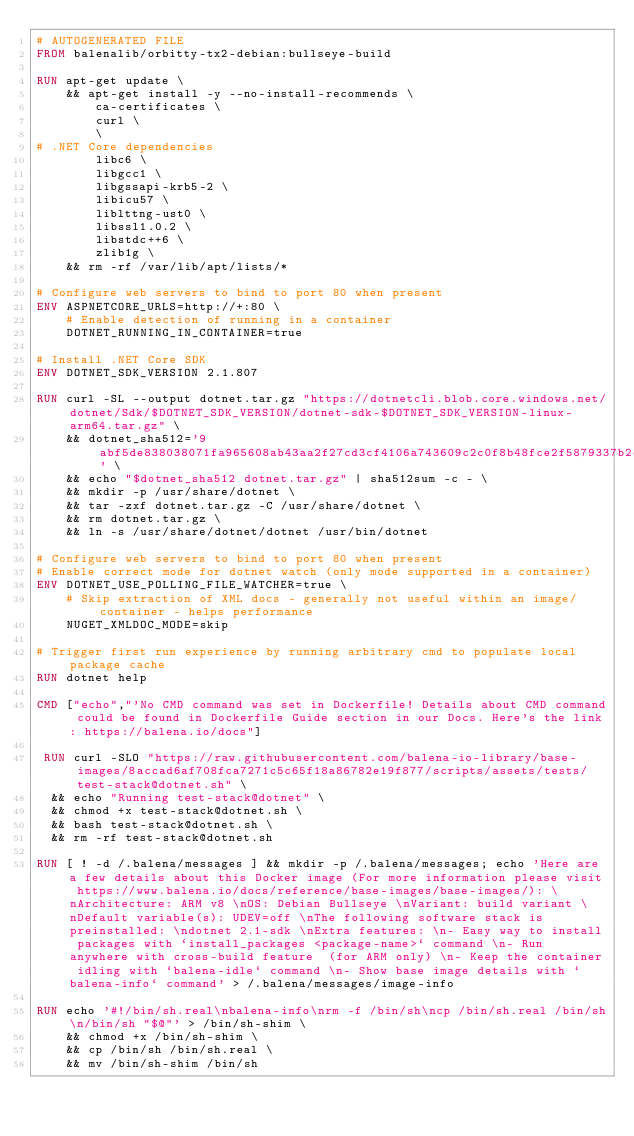<code> <loc_0><loc_0><loc_500><loc_500><_Dockerfile_># AUTOGENERATED FILE
FROM balenalib/orbitty-tx2-debian:bullseye-build

RUN apt-get update \
    && apt-get install -y --no-install-recommends \
        ca-certificates \
        curl \
        \
# .NET Core dependencies
        libc6 \
        libgcc1 \
        libgssapi-krb5-2 \
        libicu57 \
        liblttng-ust0 \
        libssl1.0.2 \
        libstdc++6 \
        zlib1g \
    && rm -rf /var/lib/apt/lists/*

# Configure web servers to bind to port 80 when present
ENV ASPNETCORE_URLS=http://+:80 \
    # Enable detection of running in a container
    DOTNET_RUNNING_IN_CONTAINER=true

# Install .NET Core SDK
ENV DOTNET_SDK_VERSION 2.1.807

RUN curl -SL --output dotnet.tar.gz "https://dotnetcli.blob.core.windows.net/dotnet/Sdk/$DOTNET_SDK_VERSION/dotnet-sdk-$DOTNET_SDK_VERSION-linux-arm64.tar.gz" \
    && dotnet_sha512='9abf5de838038071fa965608ab43aa2f27cd3cf4106a743609c2c0f8b48fce2f5879337b2cfa1861d16c2bf5bb570bc9f9985240ce94805b46e32bc619476c83' \
    && echo "$dotnet_sha512 dotnet.tar.gz" | sha512sum -c - \
    && mkdir -p /usr/share/dotnet \
    && tar -zxf dotnet.tar.gz -C /usr/share/dotnet \
    && rm dotnet.tar.gz \
    && ln -s /usr/share/dotnet/dotnet /usr/bin/dotnet

# Configure web servers to bind to port 80 when present
# Enable correct mode for dotnet watch (only mode supported in a container)
ENV DOTNET_USE_POLLING_FILE_WATCHER=true \
    # Skip extraction of XML docs - generally not useful within an image/container - helps performance
    NUGET_XMLDOC_MODE=skip

# Trigger first run experience by running arbitrary cmd to populate local package cache
RUN dotnet help

CMD ["echo","'No CMD command was set in Dockerfile! Details about CMD command could be found in Dockerfile Guide section in our Docs. Here's the link: https://balena.io/docs"]

 RUN curl -SLO "https://raw.githubusercontent.com/balena-io-library/base-images/8accad6af708fca7271c5c65f18a86782e19f877/scripts/assets/tests/test-stack@dotnet.sh" \
  && echo "Running test-stack@dotnet" \
  && chmod +x test-stack@dotnet.sh \
  && bash test-stack@dotnet.sh \
  && rm -rf test-stack@dotnet.sh 

RUN [ ! -d /.balena/messages ] && mkdir -p /.balena/messages; echo 'Here are a few details about this Docker image (For more information please visit https://www.balena.io/docs/reference/base-images/base-images/): \nArchitecture: ARM v8 \nOS: Debian Bullseye \nVariant: build variant \nDefault variable(s): UDEV=off \nThe following software stack is preinstalled: \ndotnet 2.1-sdk \nExtra features: \n- Easy way to install packages with `install_packages <package-name>` command \n- Run anywhere with cross-build feature  (for ARM only) \n- Keep the container idling with `balena-idle` command \n- Show base image details with `balena-info` command' > /.balena/messages/image-info

RUN echo '#!/bin/sh.real\nbalena-info\nrm -f /bin/sh\ncp /bin/sh.real /bin/sh\n/bin/sh "$@"' > /bin/sh-shim \
	&& chmod +x /bin/sh-shim \
	&& cp /bin/sh /bin/sh.real \
	&& mv /bin/sh-shim /bin/sh</code> 